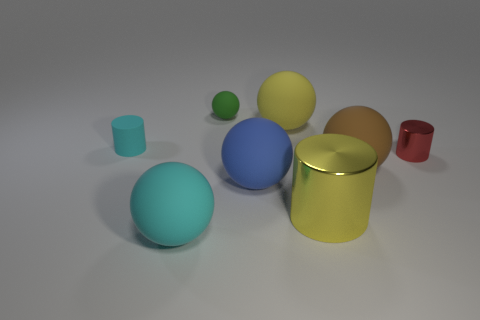Subtract all brown balls. How many balls are left? 4 Subtract all blue rubber spheres. How many spheres are left? 4 Subtract all purple balls. Subtract all brown blocks. How many balls are left? 5 Add 1 big red rubber cylinders. How many objects exist? 9 Subtract all balls. How many objects are left? 3 Add 1 small gray rubber balls. How many small gray rubber balls exist? 1 Subtract 0 red blocks. How many objects are left? 8 Subtract all cyan matte things. Subtract all brown rubber objects. How many objects are left? 5 Add 4 tiny green balls. How many tiny green balls are left? 5 